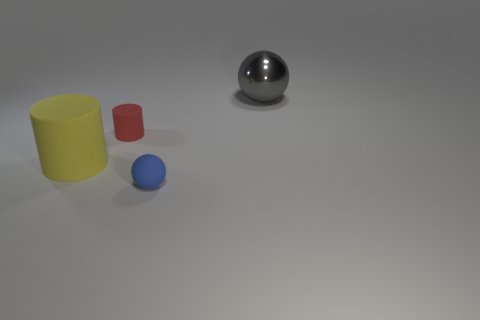Do the big object that is to the left of the blue thing and the sphere that is in front of the metallic thing have the same material?
Your answer should be very brief. Yes. Are there any matte cylinders behind the big thing that is in front of the big sphere?
Offer a terse response. Yes. There is a large object that is the same material as the blue sphere; what is its color?
Provide a short and direct response. Yellow. Are there more large gray spheres than cylinders?
Offer a terse response. No. What number of things are either large things that are to the right of the small blue matte ball or cyan shiny cylinders?
Make the answer very short. 1. Is there a gray thing that has the same size as the gray metallic sphere?
Provide a succinct answer. No. Are there fewer small cyan matte blocks than small balls?
Your response must be concise. Yes. What number of spheres are either big red matte objects or big gray metal things?
Your response must be concise. 1. What is the size of the thing that is both left of the tiny blue thing and behind the big cylinder?
Your answer should be very brief. Small. Are there fewer small cylinders that are in front of the yellow rubber cylinder than big shiny spheres?
Give a very brief answer. Yes. 